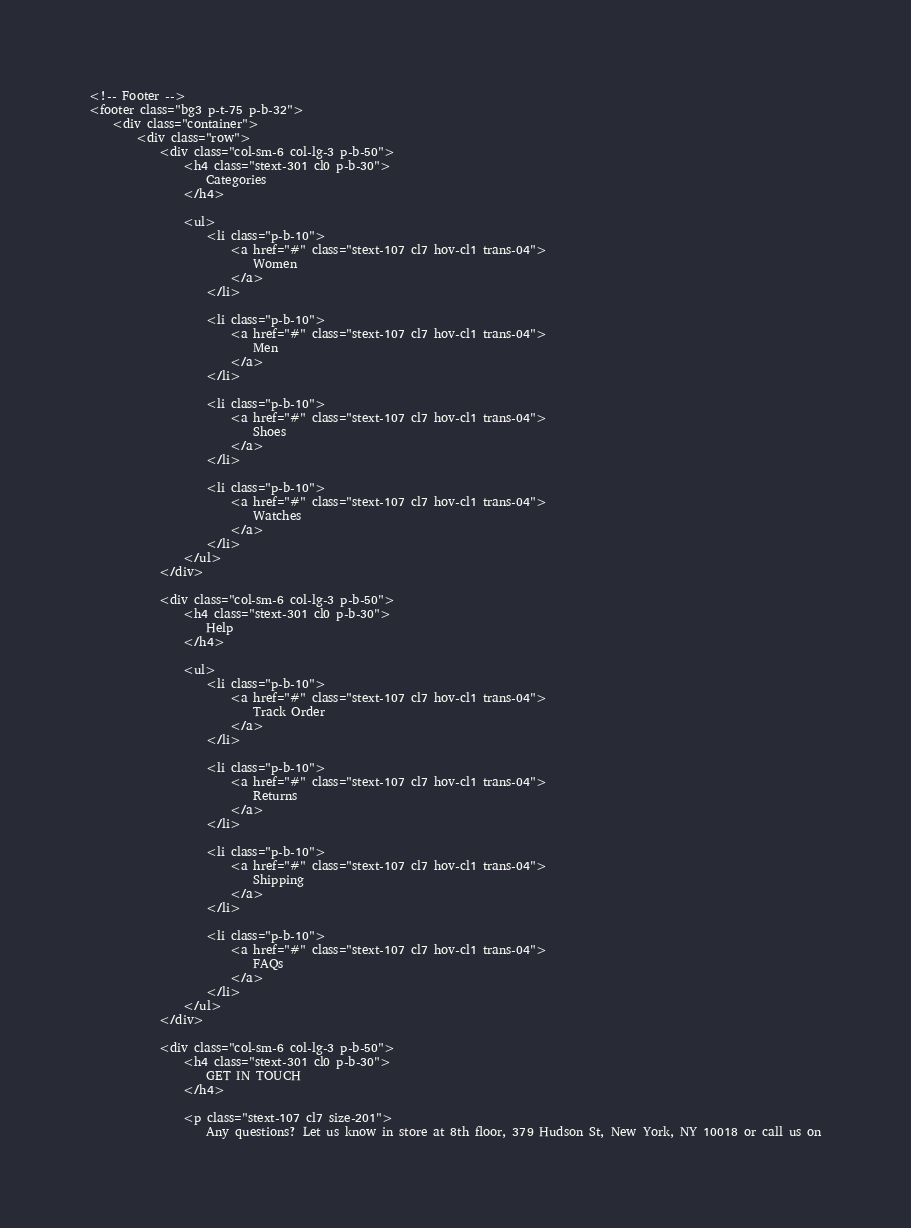<code> <loc_0><loc_0><loc_500><loc_500><_PHP_>
<!-- Footer -->
<footer class="bg3 p-t-75 p-b-32">
    <div class="container">
        <div class="row">
            <div class="col-sm-6 col-lg-3 p-b-50">
                <h4 class="stext-301 cl0 p-b-30">
                    Categories
                </h4>

                <ul>
                    <li class="p-b-10">
                        <a href="#" class="stext-107 cl7 hov-cl1 trans-04">
                            Women
                        </a>
                    </li>

                    <li class="p-b-10">
                        <a href="#" class="stext-107 cl7 hov-cl1 trans-04">
                            Men
                        </a>
                    </li>

                    <li class="p-b-10">
                        <a href="#" class="stext-107 cl7 hov-cl1 trans-04">
                            Shoes
                        </a>
                    </li>

                    <li class="p-b-10">
                        <a href="#" class="stext-107 cl7 hov-cl1 trans-04">
                            Watches
                        </a>
                    </li>
                </ul>
            </div>

            <div class="col-sm-6 col-lg-3 p-b-50">
                <h4 class="stext-301 cl0 p-b-30">
                    Help
                </h4>

                <ul>
                    <li class="p-b-10">
                        <a href="#" class="stext-107 cl7 hov-cl1 trans-04">
                            Track Order
                        </a>
                    </li>

                    <li class="p-b-10">
                        <a href="#" class="stext-107 cl7 hov-cl1 trans-04">
                            Returns
                        </a>
                    </li>

                    <li class="p-b-10">
                        <a href="#" class="stext-107 cl7 hov-cl1 trans-04">
                            Shipping
                        </a>
                    </li>

                    <li class="p-b-10">
                        <a href="#" class="stext-107 cl7 hov-cl1 trans-04">
                            FAQs
                        </a>
                    </li>
                </ul>
            </div>

            <div class="col-sm-6 col-lg-3 p-b-50">
                <h4 class="stext-301 cl0 p-b-30">
                    GET IN TOUCH
                </h4>

                <p class="stext-107 cl7 size-201">
                    Any questions? Let us know in store at 8th floor, 379 Hudson St, New York, NY 10018 or call us on</code> 